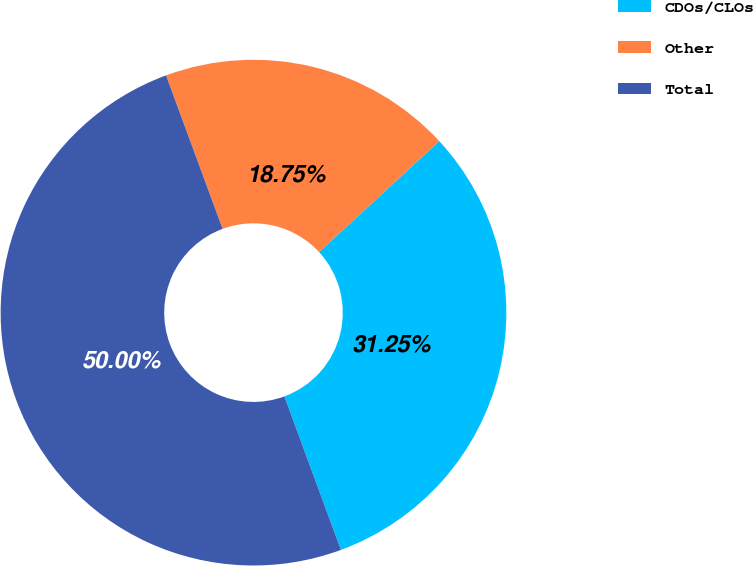<chart> <loc_0><loc_0><loc_500><loc_500><pie_chart><fcel>CDOs/CLOs<fcel>Other<fcel>Total<nl><fcel>31.25%<fcel>18.75%<fcel>50.0%<nl></chart> 